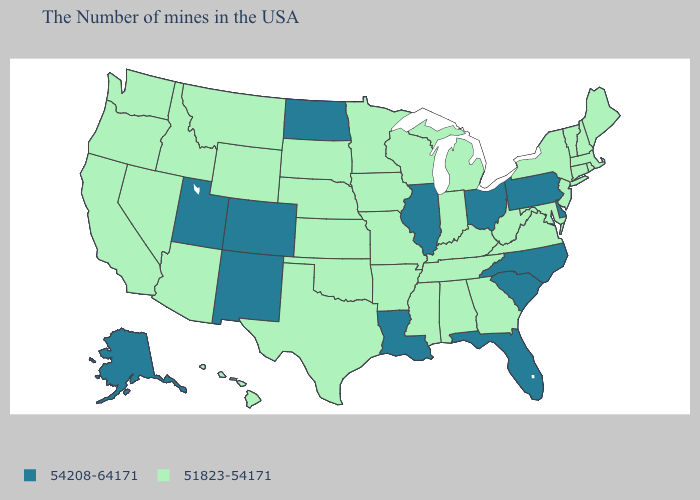How many symbols are there in the legend?
Concise answer only. 2. Does Alaska have the lowest value in the West?
Concise answer only. No. What is the value of Connecticut?
Be succinct. 51823-54171. Among the states that border West Virginia , which have the highest value?
Write a very short answer. Pennsylvania, Ohio. Name the states that have a value in the range 51823-54171?
Concise answer only. Maine, Massachusetts, Rhode Island, New Hampshire, Vermont, Connecticut, New York, New Jersey, Maryland, Virginia, West Virginia, Georgia, Michigan, Kentucky, Indiana, Alabama, Tennessee, Wisconsin, Mississippi, Missouri, Arkansas, Minnesota, Iowa, Kansas, Nebraska, Oklahoma, Texas, South Dakota, Wyoming, Montana, Arizona, Idaho, Nevada, California, Washington, Oregon, Hawaii. What is the lowest value in the USA?
Give a very brief answer. 51823-54171. Which states have the lowest value in the USA?
Answer briefly. Maine, Massachusetts, Rhode Island, New Hampshire, Vermont, Connecticut, New York, New Jersey, Maryland, Virginia, West Virginia, Georgia, Michigan, Kentucky, Indiana, Alabama, Tennessee, Wisconsin, Mississippi, Missouri, Arkansas, Minnesota, Iowa, Kansas, Nebraska, Oklahoma, Texas, South Dakota, Wyoming, Montana, Arizona, Idaho, Nevada, California, Washington, Oregon, Hawaii. Among the states that border Maryland , which have the lowest value?
Keep it brief. Virginia, West Virginia. What is the lowest value in states that border Alabama?
Quick response, please. 51823-54171. What is the highest value in the USA?
Write a very short answer. 54208-64171. How many symbols are there in the legend?
Short answer required. 2. Which states hav the highest value in the South?
Concise answer only. Delaware, North Carolina, South Carolina, Florida, Louisiana. Does Kansas have the lowest value in the MidWest?
Quick response, please. Yes. Name the states that have a value in the range 54208-64171?
Be succinct. Delaware, Pennsylvania, North Carolina, South Carolina, Ohio, Florida, Illinois, Louisiana, North Dakota, Colorado, New Mexico, Utah, Alaska. Name the states that have a value in the range 51823-54171?
Answer briefly. Maine, Massachusetts, Rhode Island, New Hampshire, Vermont, Connecticut, New York, New Jersey, Maryland, Virginia, West Virginia, Georgia, Michigan, Kentucky, Indiana, Alabama, Tennessee, Wisconsin, Mississippi, Missouri, Arkansas, Minnesota, Iowa, Kansas, Nebraska, Oklahoma, Texas, South Dakota, Wyoming, Montana, Arizona, Idaho, Nevada, California, Washington, Oregon, Hawaii. 